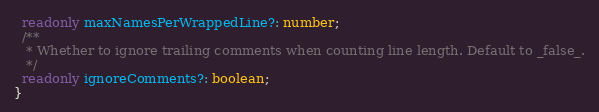Convert code to text. <code><loc_0><loc_0><loc_500><loc_500><_TypeScript_>  readonly maxNamesPerWrappedLine?: number;
  /**
   * Whether to ignore trailing comments when counting line length. Default to _false_.
   */
  readonly ignoreComments?: boolean;
}
</code> 